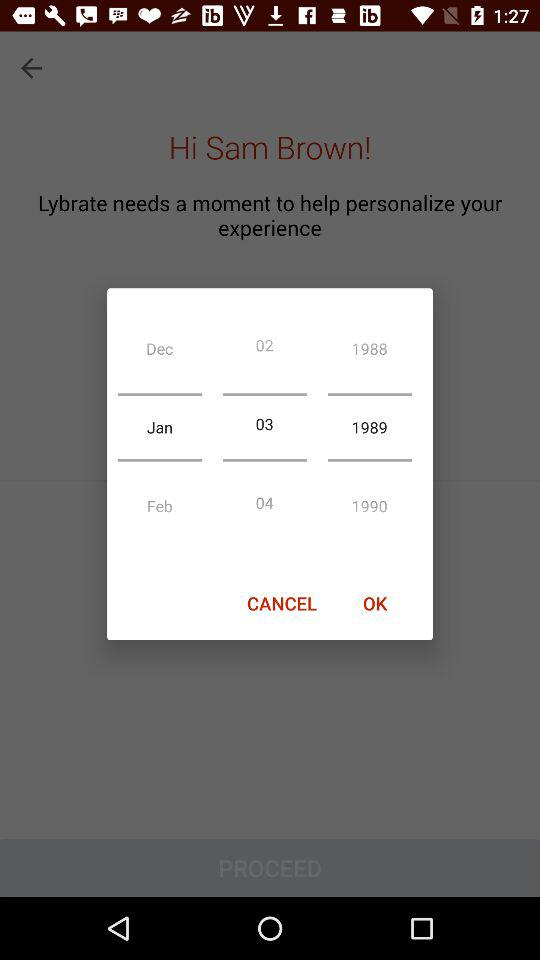How many years are represented by the text elements?
Answer the question using a single word or phrase. 3 